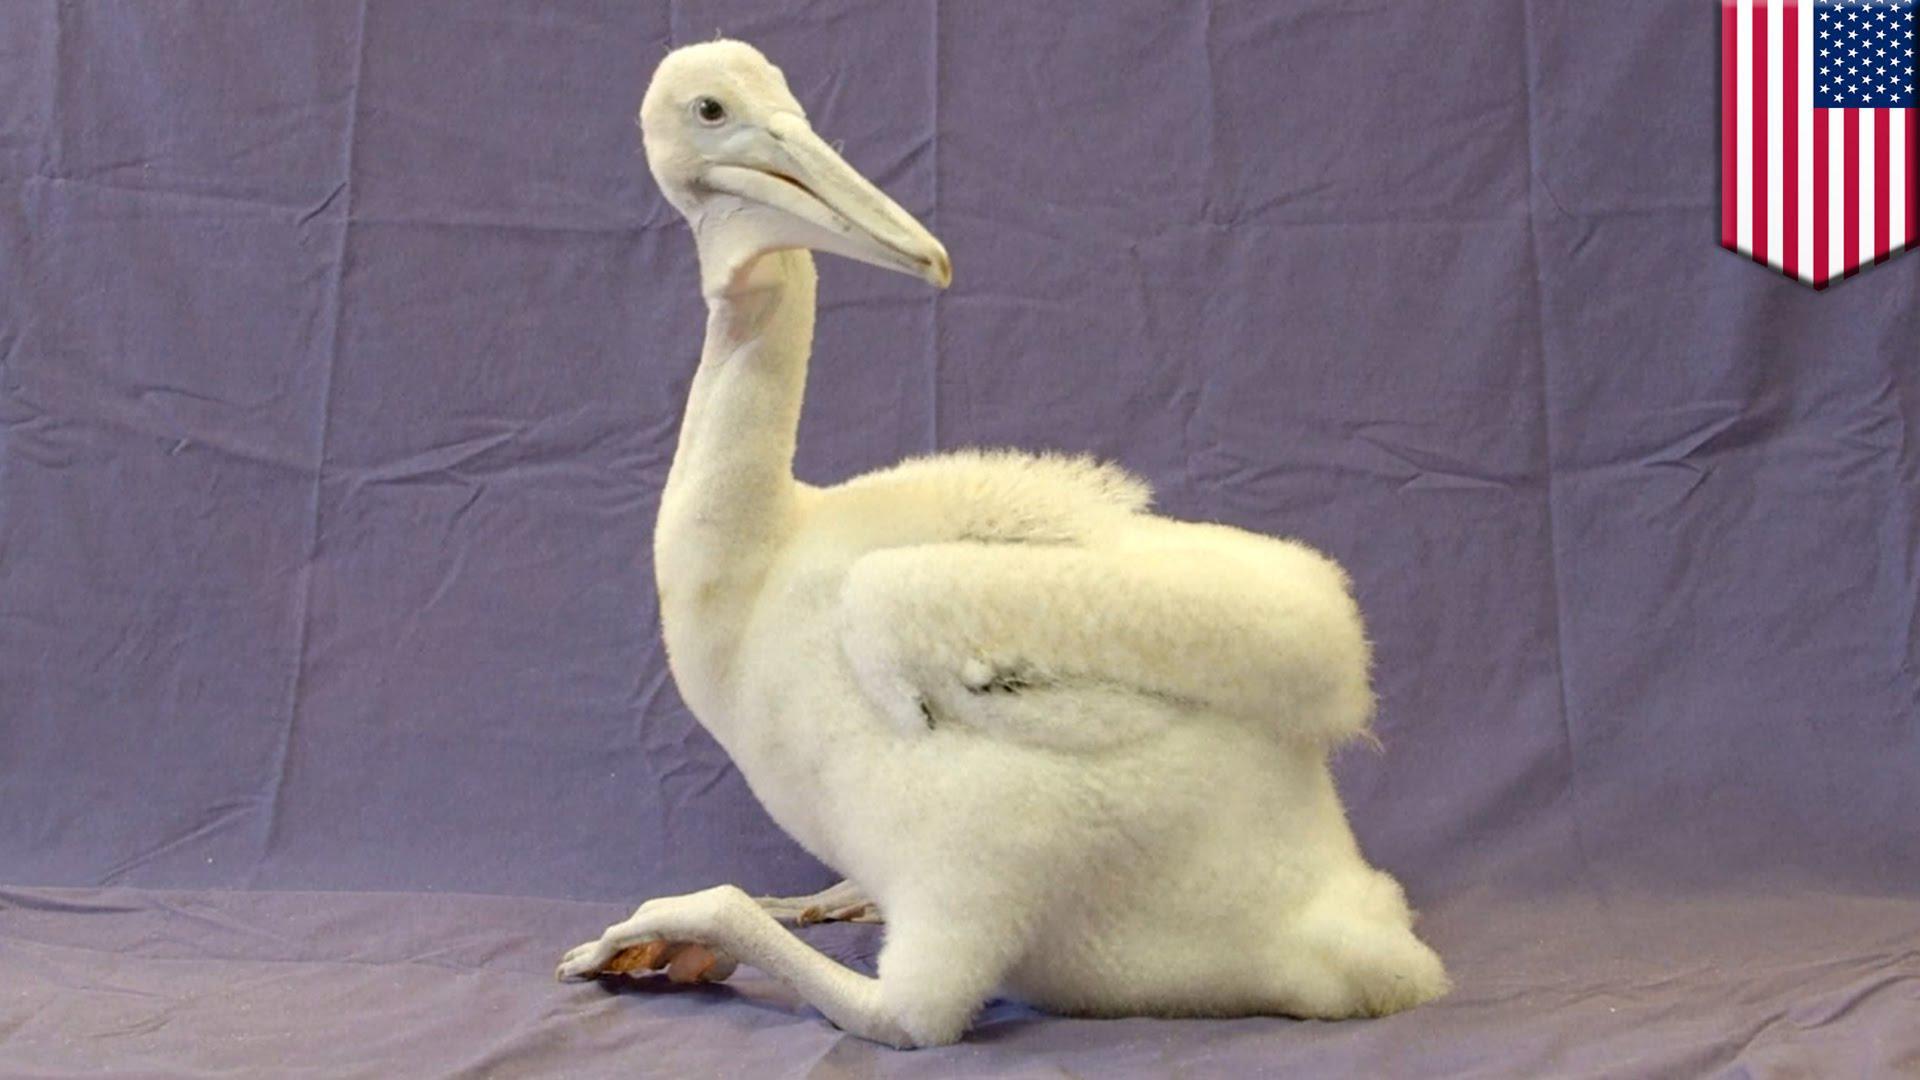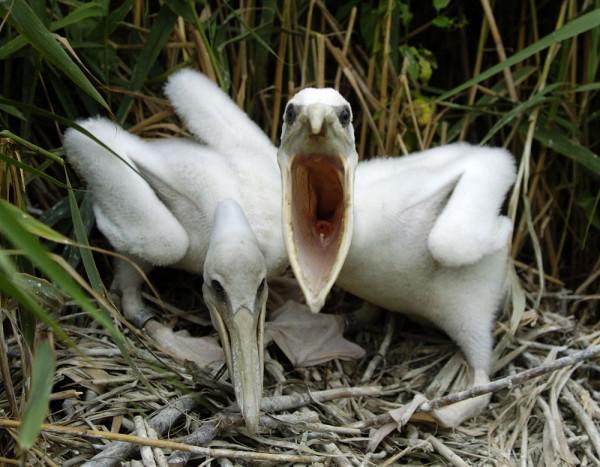The first image is the image on the left, the second image is the image on the right. Evaluate the accuracy of this statement regarding the images: "An image shows a nest that includes a pelican with an open mouth in it.". Is it true? Answer yes or no. Yes. The first image is the image on the left, the second image is the image on the right. Considering the images on both sides, is "The bird in the image on the right is in a wet area." valid? Answer yes or no. No. 